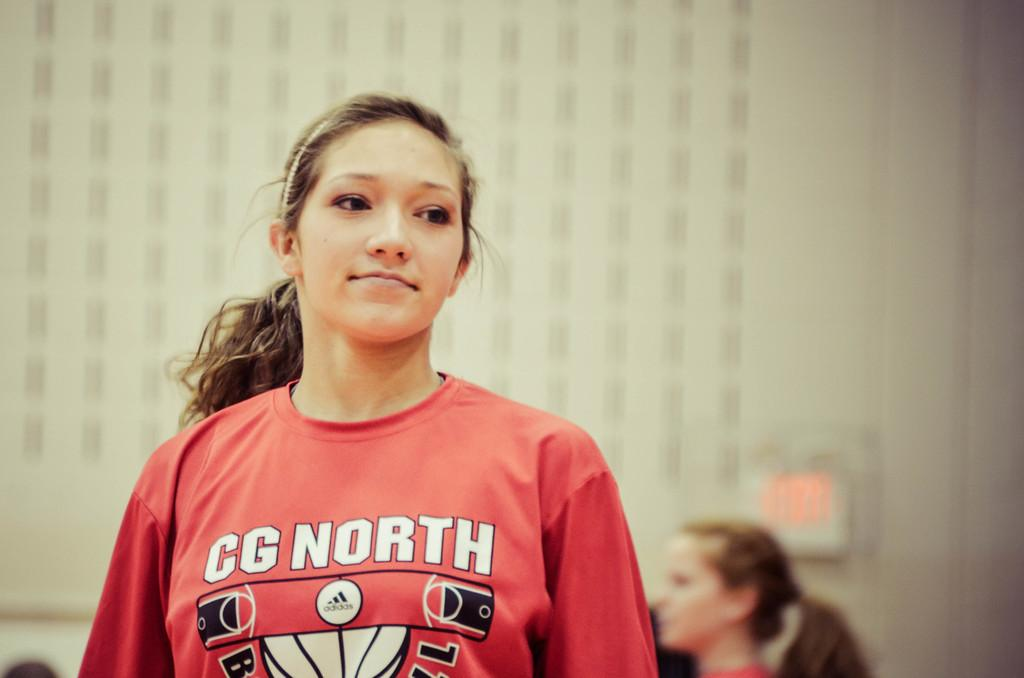<image>
Relay a brief, clear account of the picture shown. A woman wearing a CG North long sleeve shirt looking distracted and behind her another woman looking to the forward to the left of the woman in front. 